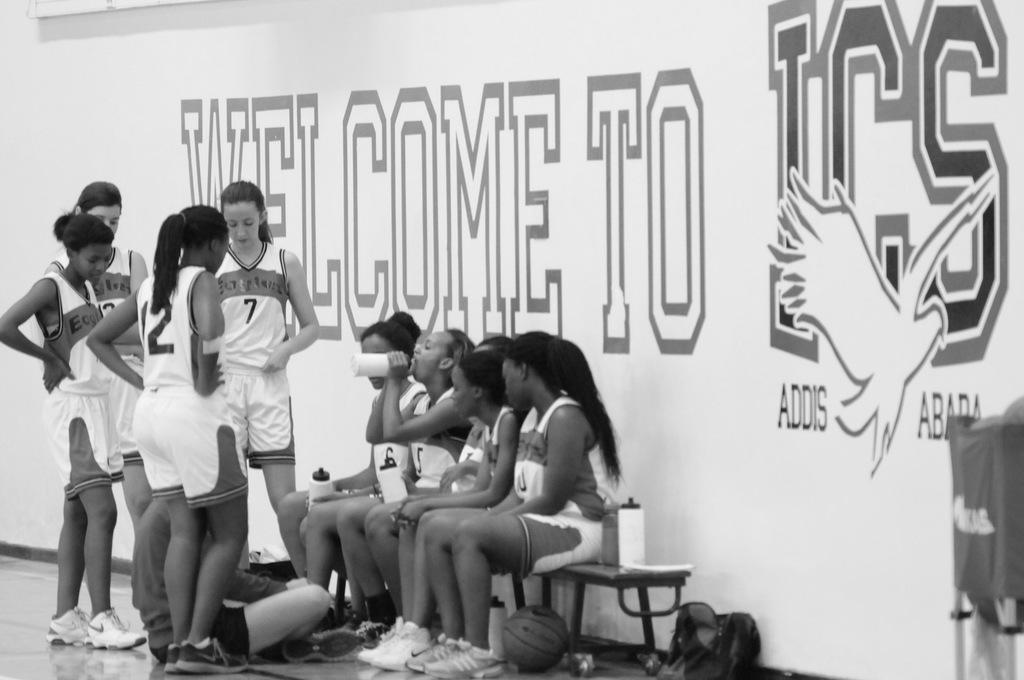How would you summarize this image in a sentence or two? In this image we can see black and white picture of a group of people standing, some are sitting and holding bottles in their hand. At the bottom of the image we can see a ball, bottle and a bag placed on the ground. On the right side of the image we can see a chair. At the top of the image we can see a banner with some text. 